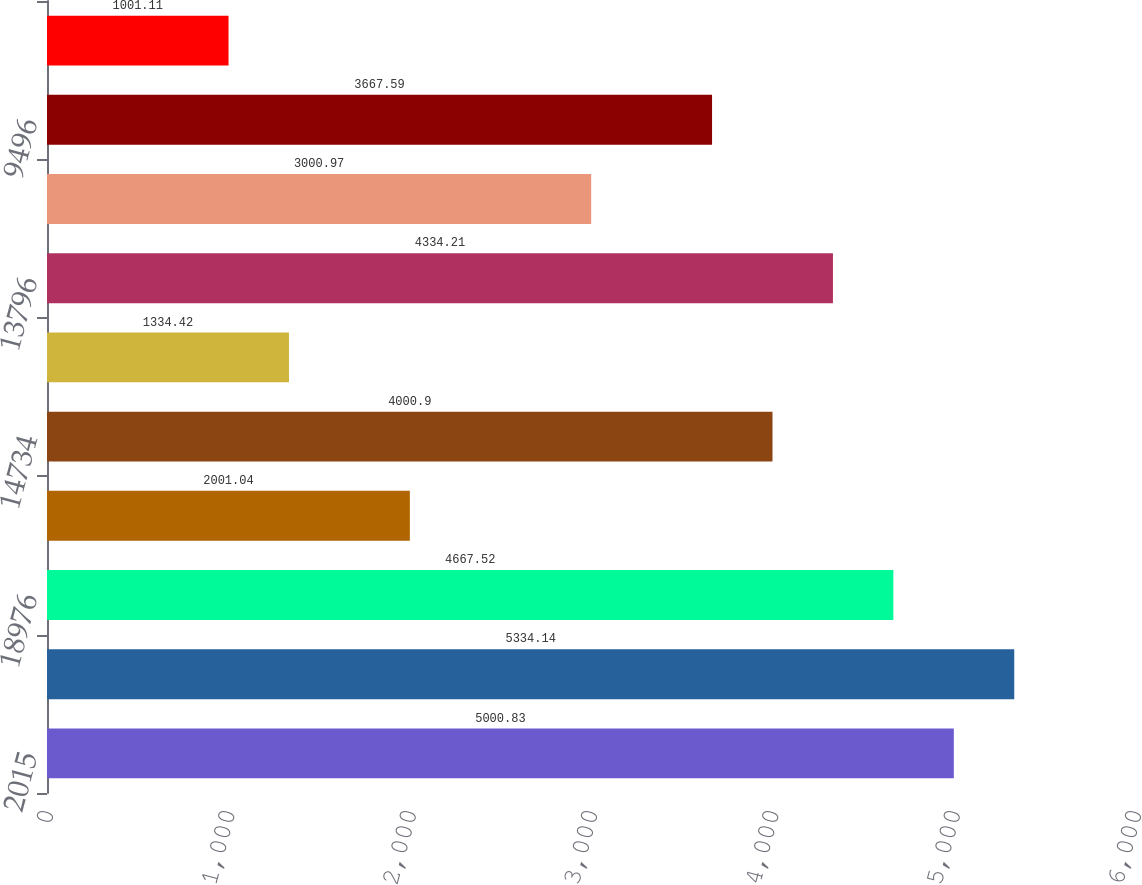Convert chart. <chart><loc_0><loc_0><loc_500><loc_500><bar_chart><fcel>2015<fcel>34845<fcel>18976<fcel>1135<fcel>14734<fcel>(938)<fcel>13796<fcel>4300<fcel>9496<fcel>83<nl><fcel>5000.83<fcel>5334.14<fcel>4667.52<fcel>2001.04<fcel>4000.9<fcel>1334.42<fcel>4334.21<fcel>3000.97<fcel>3667.59<fcel>1001.11<nl></chart> 